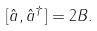Convert formula to latex. <formula><loc_0><loc_0><loc_500><loc_500>[ \hat { a } , \hat { a } ^ { \dag } ] = 2 B .</formula> 